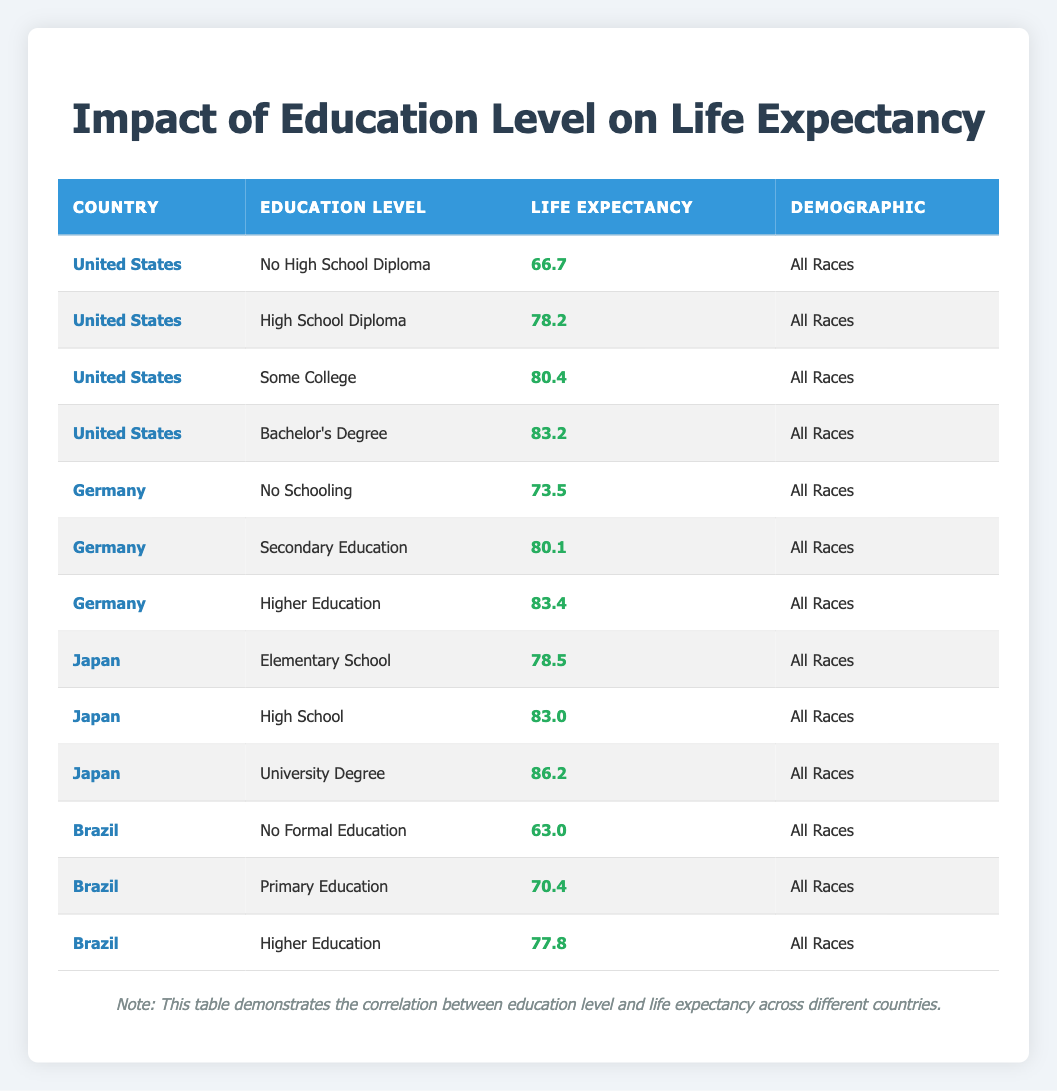What is the life expectancy for individuals with a Bachelor's Degree in the United States? According to the table, individuals with a Bachelor's Degree in the United States have a life expectancy of 83.2 years.
Answer: 83.2 Which country has the lowest life expectancy for individuals with No High School Diploma? The table shows that Brazil has the lowest life expectancy for individuals with No Formal Education at 63.0 years. Among the United States, Germany, and Brazil, the 63.0 from Brazil is the lowest.
Answer: Brazil: 63.0 What is the difference in life expectancy between individuals with No Schooling in Germany and No High School Diploma in the United States? The life expectancy for individuals with No Schooling in Germany is 73.5 years, while for No High School Diploma in the United States, it is 66.7 years. The difference is 73.5 - 66.7 = 6.8 years.
Answer: 6.8 years Is the life expectancy for individuals with Secondary Education in Germany higher than the life expectancy for those with Primary Education in Brazil? The table indicates that the life expectancy for Secondary Education in Germany is 80.1 years, while for Primary Education in Brazil, it is 70.4 years. Thus, the former is indeed higher.
Answer: Yes What is the average life expectancy for all education levels in Japan? The life expectancies in Japan are 78.5 (Elementary School), 83.0 (High School), and 86.2 (University Degree). To find the average, sum these values (78.5 + 83.0 + 86.2 = 247.7) and divide by the number of data points (3). Thus, the average is 247.7 / 3 = 82.5667.
Answer: 82.57 